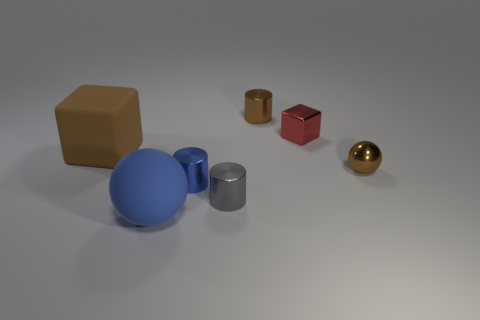Add 3 tiny red objects. How many objects exist? 10 Subtract all balls. How many objects are left? 5 Subtract all blue metal things. Subtract all metallic objects. How many objects are left? 1 Add 2 metallic objects. How many metallic objects are left? 7 Add 2 large brown matte objects. How many large brown matte objects exist? 3 Subtract 1 brown spheres. How many objects are left? 6 